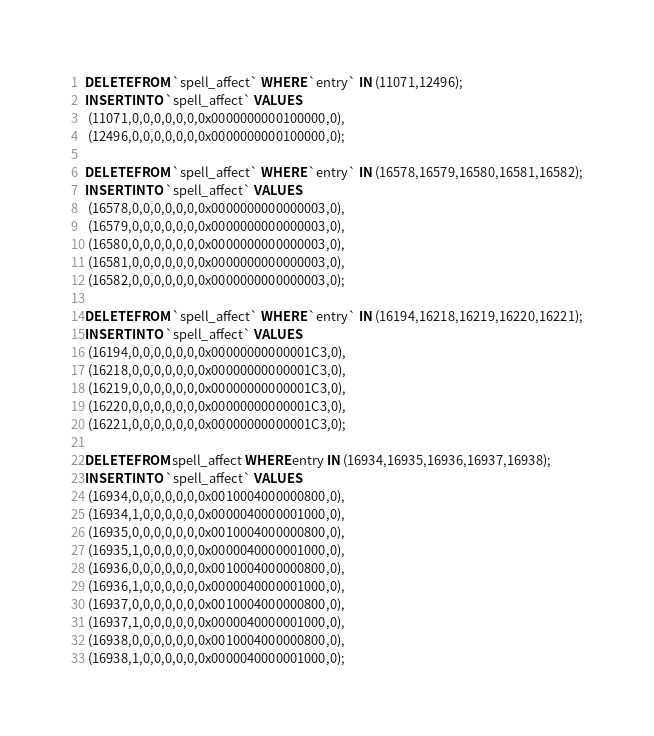Convert code to text. <code><loc_0><loc_0><loc_500><loc_500><_SQL_>DELETE FROM `spell_affect` WHERE `entry` IN (11071,12496);
INSERT INTO `spell_affect` VALUES
 (11071,0,0,0,0,0,0,0x0000000000100000,0),
 (12496,0,0,0,0,0,0,0x0000000000100000,0);

DELETE FROM `spell_affect` WHERE `entry` IN (16578,16579,16580,16581,16582);
INSERT INTO `spell_affect` VALUES
 (16578,0,0,0,0,0,0,0x0000000000000003,0),
 (16579,0,0,0,0,0,0,0x0000000000000003,0),
 (16580,0,0,0,0,0,0,0x0000000000000003,0),
 (16581,0,0,0,0,0,0,0x0000000000000003,0),
 (16582,0,0,0,0,0,0,0x0000000000000003,0);

DELETE FROM `spell_affect` WHERE `entry` IN (16194,16218,16219,16220,16221);
INSERT INTO `spell_affect` VALUES
 (16194,0,0,0,0,0,0,0x00000000000001C3,0),
 (16218,0,0,0,0,0,0,0x00000000000001C3,0),
 (16219,0,0,0,0,0,0,0x00000000000001C3,0),
 (16220,0,0,0,0,0,0,0x00000000000001C3,0),
 (16221,0,0,0,0,0,0,0x00000000000001C3,0);

DELETE FROM spell_affect WHERE entry IN (16934,16935,16936,16937,16938);
INSERT INTO `spell_affect` VALUES
 (16934,0,0,0,0,0,0,0x0010004000000800,0),
 (16934,1,0,0,0,0,0,0x0000040000001000,0),
 (16935,0,0,0,0,0,0,0x0010004000000800,0),
 (16935,1,0,0,0,0,0,0x0000040000001000,0),
 (16936,0,0,0,0,0,0,0x0010004000000800,0),
 (16936,1,0,0,0,0,0,0x0000040000001000,0),
 (16937,0,0,0,0,0,0,0x0010004000000800,0),
 (16937,1,0,0,0,0,0,0x0000040000001000,0),
 (16938,0,0,0,0,0,0,0x0010004000000800,0),
 (16938,1,0,0,0,0,0,0x0000040000001000,0);
</code> 